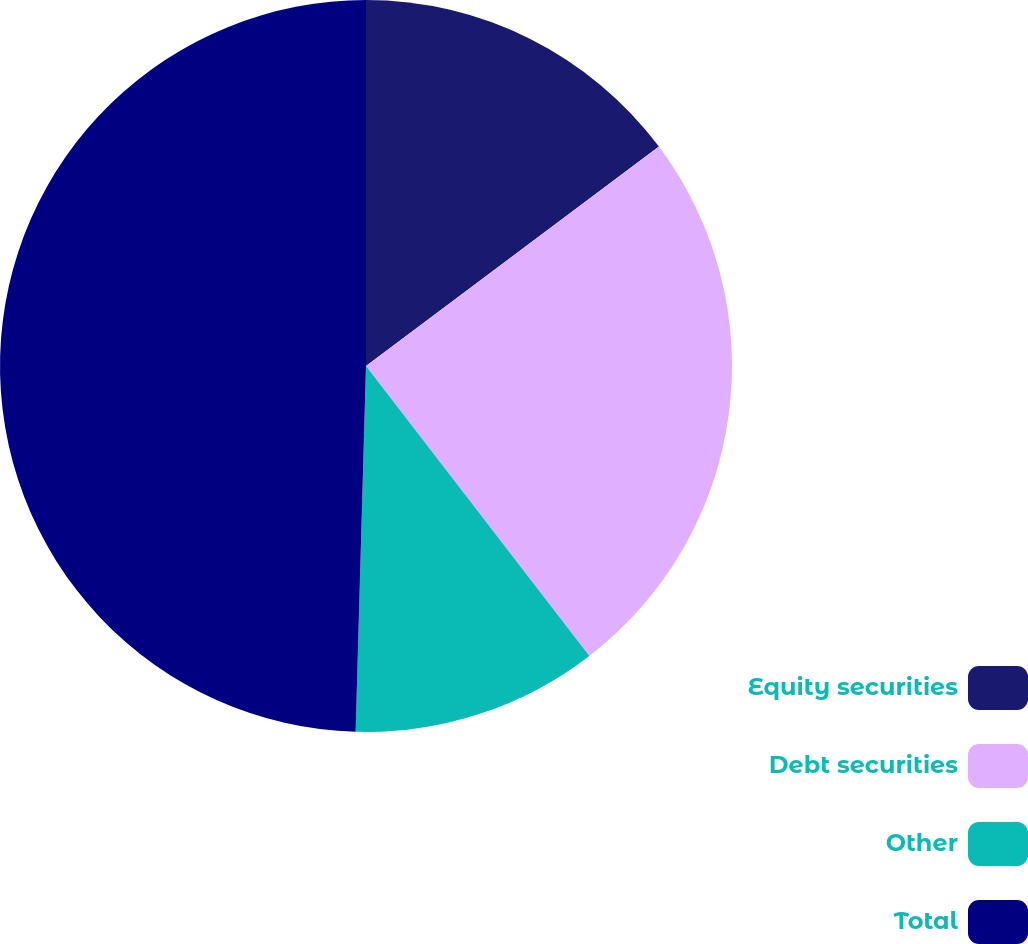Convert chart. <chart><loc_0><loc_0><loc_500><loc_500><pie_chart><fcel>Equity securities<fcel>Debt securities<fcel>Other<fcel>Total<nl><fcel>14.77%<fcel>24.78%<fcel>10.9%<fcel>49.55%<nl></chart> 